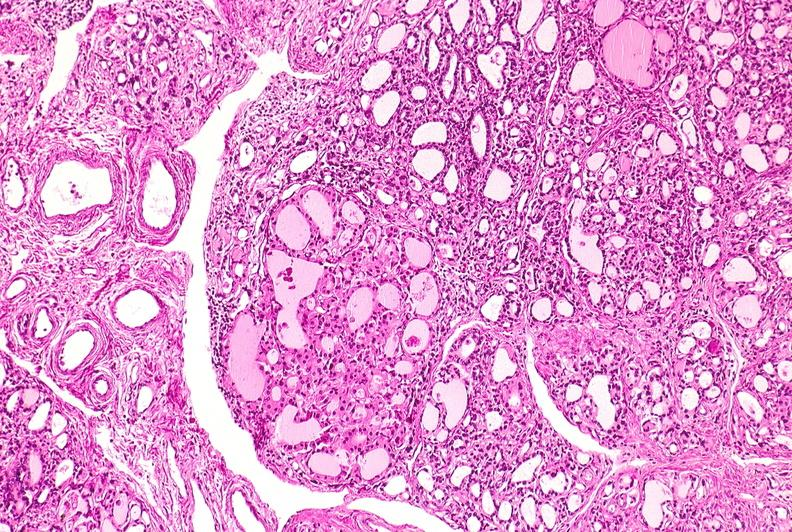does case of peritonitis slide show thyroid, hashimoto 's?
Answer the question using a single word or phrase. No 